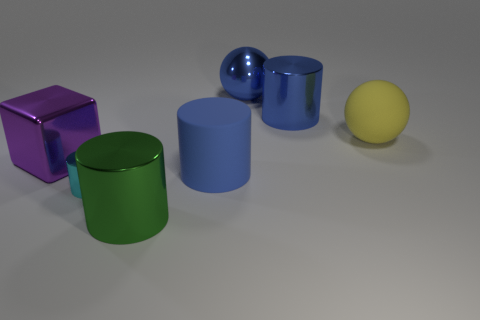How big is the cylinder that is behind the cube?
Make the answer very short. Large. Is the number of large blue metallic objects greater than the number of big gray metal cylinders?
Keep it short and to the point. Yes. What is the small cyan object made of?
Provide a succinct answer. Metal. How many other things are there of the same material as the cube?
Your answer should be very brief. 4. How many tiny blocks are there?
Make the answer very short. 0. There is another object that is the same shape as the yellow object; what is it made of?
Your answer should be compact. Metal. Are the cylinder that is left of the big green object and the big yellow ball made of the same material?
Keep it short and to the point. No. Is the number of blue spheres right of the big purple metallic thing greater than the number of metal cylinders left of the cyan shiny cylinder?
Your answer should be compact. Yes. What size is the blue sphere?
Offer a very short reply. Large. What is the shape of the big blue object that is the same material as the blue sphere?
Provide a short and direct response. Cylinder. 